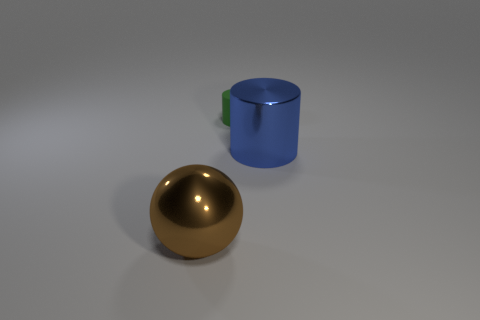Does the object to the right of the green cylinder have the same material as the brown thing?
Your answer should be very brief. Yes. Are there more big blue metallic cylinders that are on the right side of the big blue metallic cylinder than tiny matte objects left of the small cylinder?
Your answer should be compact. No. The brown thing has what size?
Keep it short and to the point. Large. The other object that is made of the same material as the brown thing is what shape?
Ensure brevity in your answer.  Cylinder. Do the thing left of the rubber cylinder and the green rubber thing have the same shape?
Your answer should be very brief. No. What number of objects are either big brown metal objects or red metallic balls?
Keep it short and to the point. 1. What is the thing that is on the right side of the big metal ball and left of the blue cylinder made of?
Keep it short and to the point. Rubber. Is the size of the green matte cylinder the same as the blue cylinder?
Give a very brief answer. No. There is a thing in front of the big shiny thing right of the small cylinder; what size is it?
Ensure brevity in your answer.  Large. What number of cylinders are behind the large blue object and on the right side of the tiny green cylinder?
Keep it short and to the point. 0. 